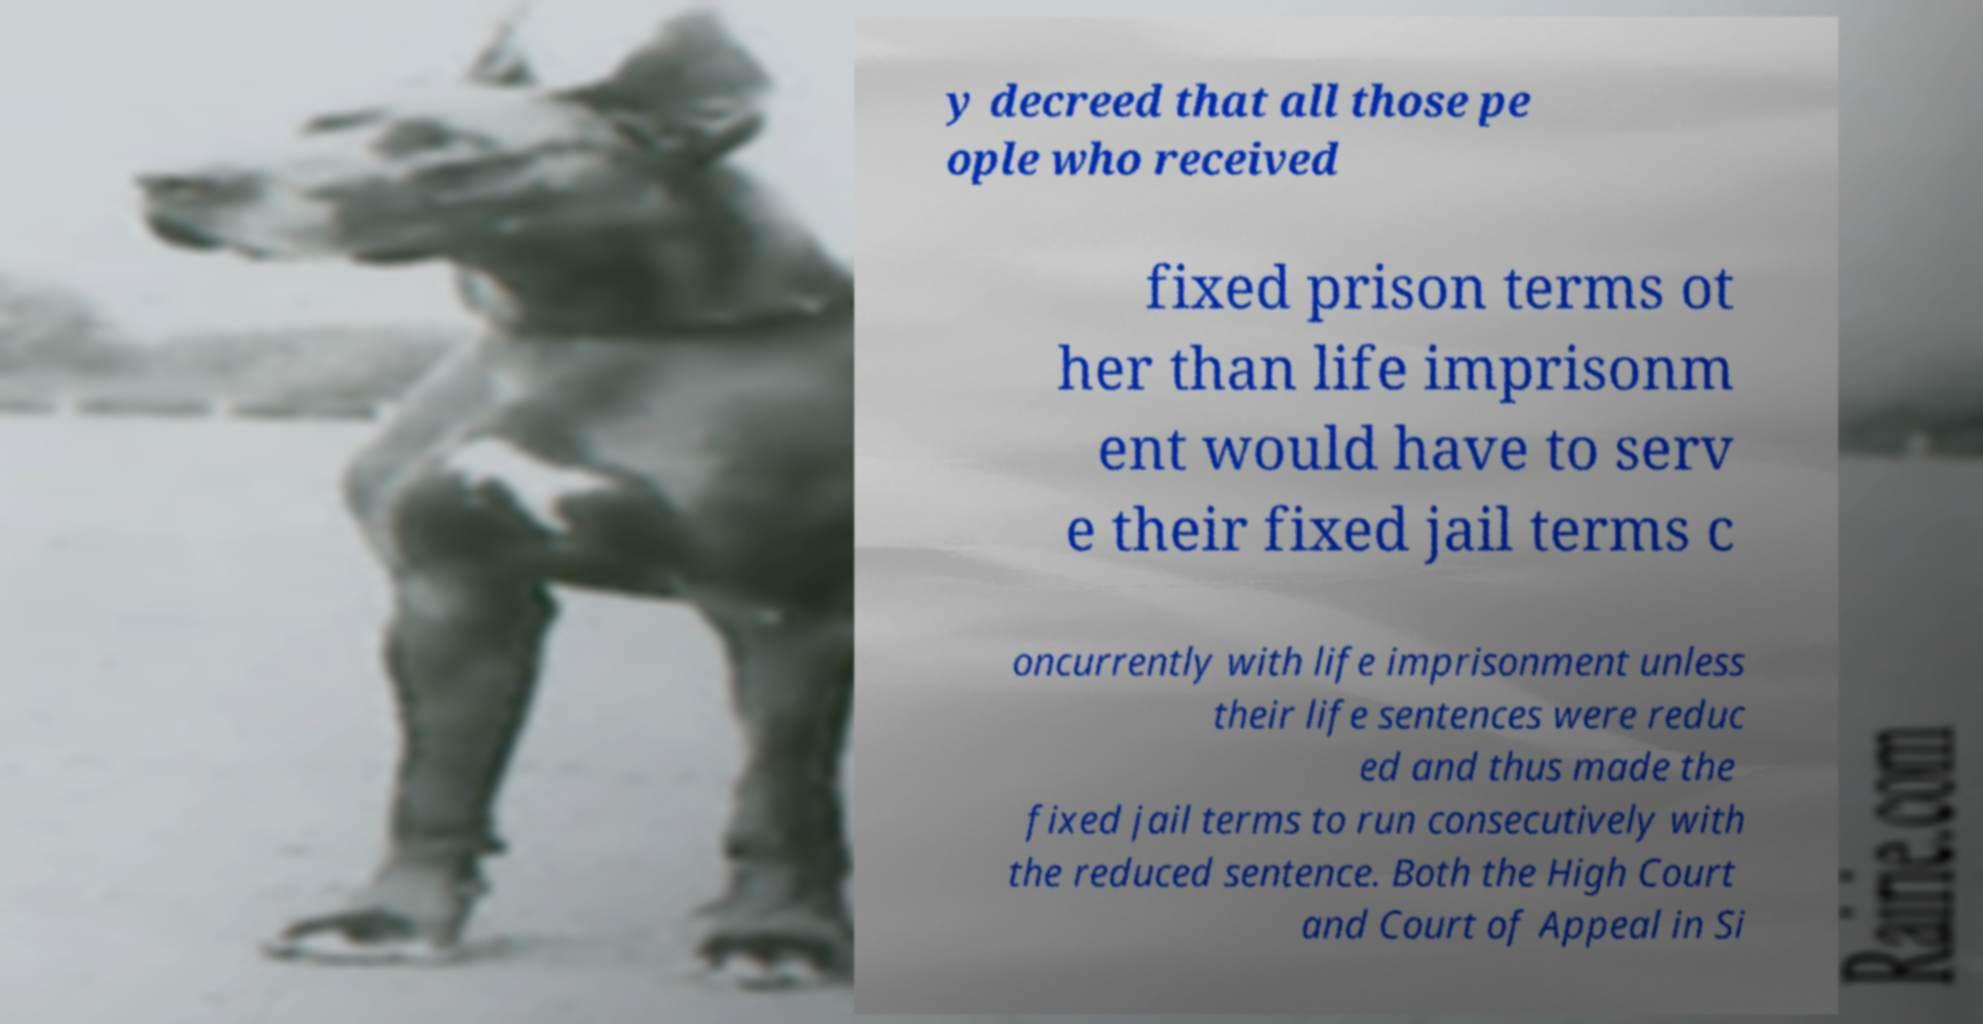For documentation purposes, I need the text within this image transcribed. Could you provide that? y decreed that all those pe ople who received fixed prison terms ot her than life imprisonm ent would have to serv e their fixed jail terms c oncurrently with life imprisonment unless their life sentences were reduc ed and thus made the fixed jail terms to run consecutively with the reduced sentence. Both the High Court and Court of Appeal in Si 